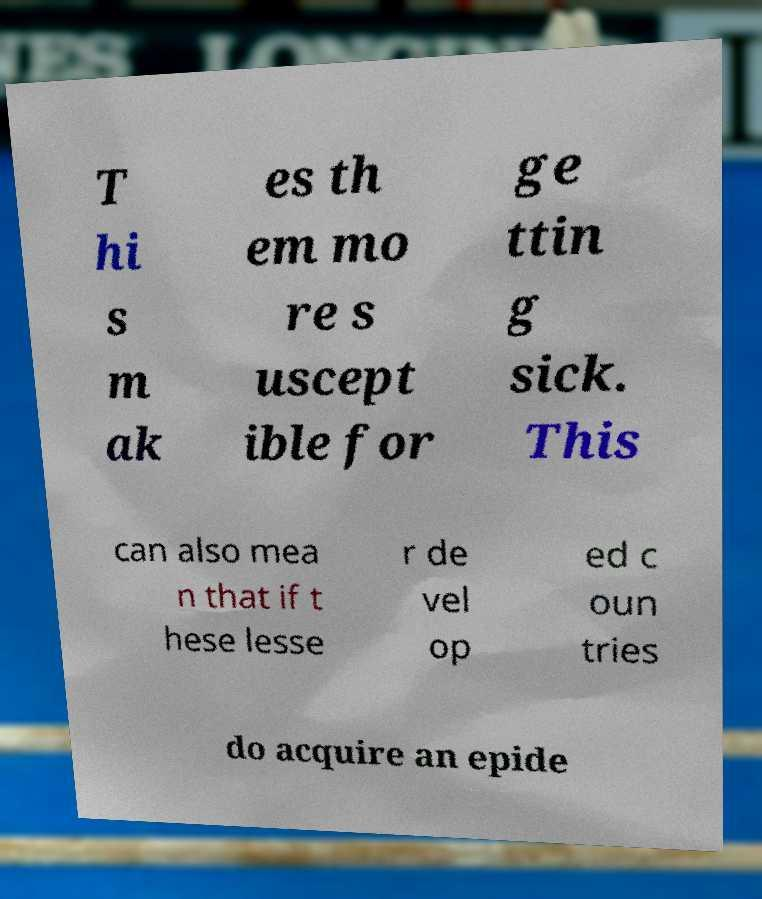I need the written content from this picture converted into text. Can you do that? T hi s m ak es th em mo re s uscept ible for ge ttin g sick. This can also mea n that if t hese lesse r de vel op ed c oun tries do acquire an epide 